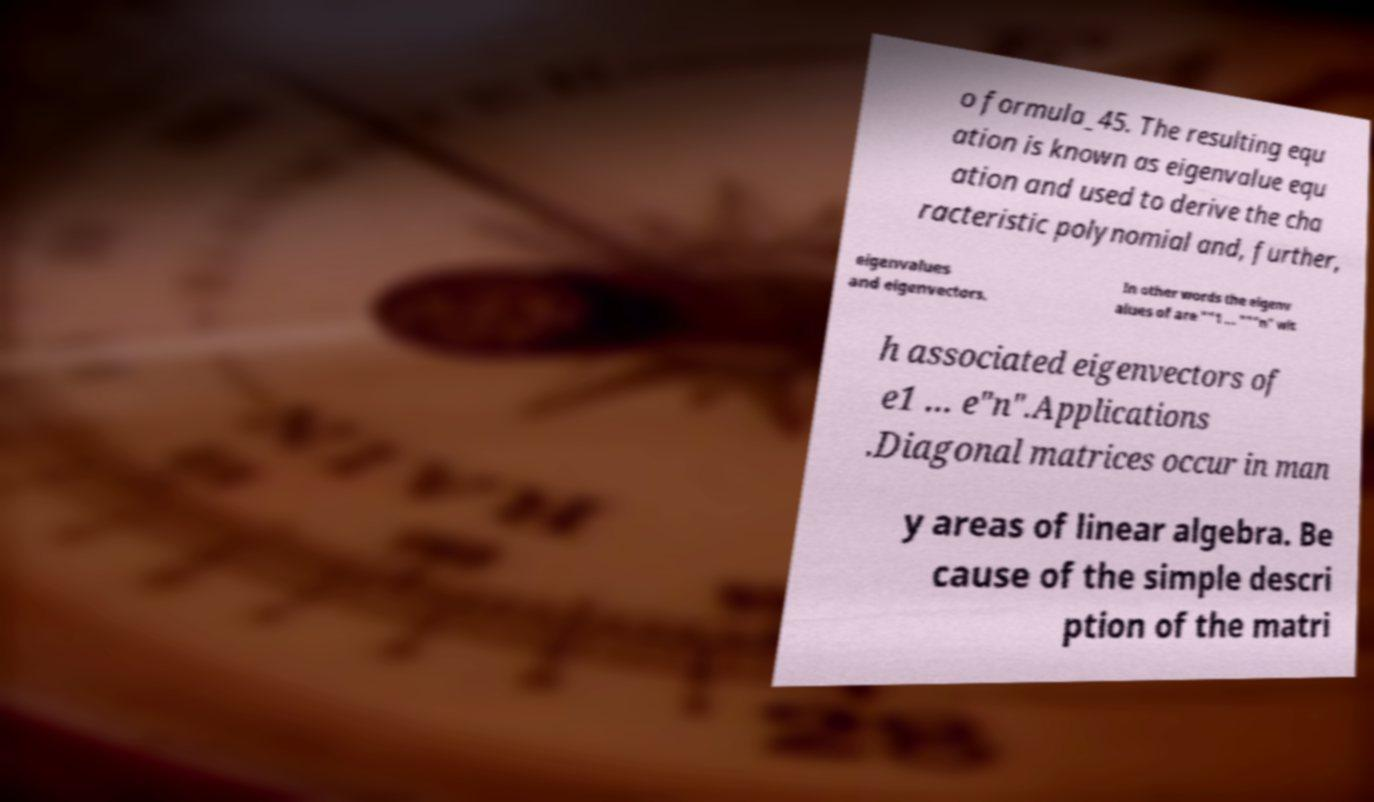Can you accurately transcribe the text from the provided image for me? o formula_45. The resulting equ ation is known as eigenvalue equ ation and used to derive the cha racteristic polynomial and, further, eigenvalues and eigenvectors. In other words the eigenv alues of are ""1 … """n" wit h associated eigenvectors of e1 … e"n".Applications .Diagonal matrices occur in man y areas of linear algebra. Be cause of the simple descri ption of the matri 